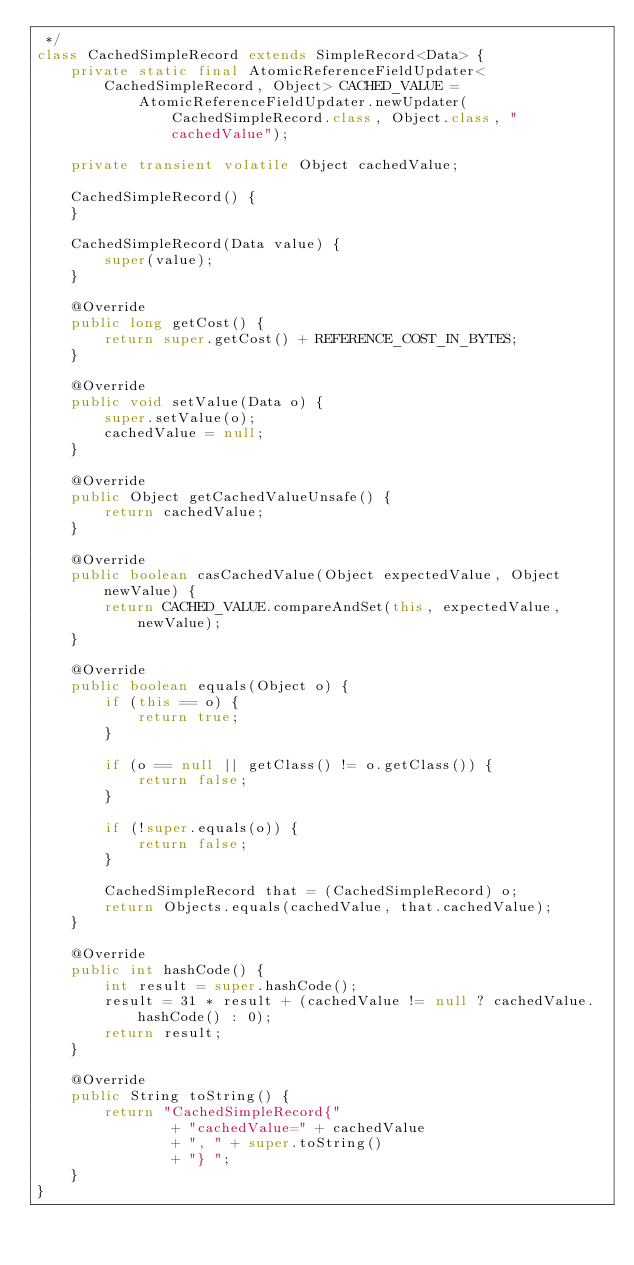<code> <loc_0><loc_0><loc_500><loc_500><_Java_> */
class CachedSimpleRecord extends SimpleRecord<Data> {
    private static final AtomicReferenceFieldUpdater<CachedSimpleRecord, Object> CACHED_VALUE =
            AtomicReferenceFieldUpdater.newUpdater(CachedSimpleRecord.class, Object.class, "cachedValue");

    private transient volatile Object cachedValue;

    CachedSimpleRecord() {
    }

    CachedSimpleRecord(Data value) {
        super(value);
    }

    @Override
    public long getCost() {
        return super.getCost() + REFERENCE_COST_IN_BYTES;
    }

    @Override
    public void setValue(Data o) {
        super.setValue(o);
        cachedValue = null;
    }

    @Override
    public Object getCachedValueUnsafe() {
        return cachedValue;
    }

    @Override
    public boolean casCachedValue(Object expectedValue, Object newValue) {
        return CACHED_VALUE.compareAndSet(this, expectedValue, newValue);
    }

    @Override
    public boolean equals(Object o) {
        if (this == o) {
            return true;
        }

        if (o == null || getClass() != o.getClass()) {
            return false;
        }

        if (!super.equals(o)) {
            return false;
        }

        CachedSimpleRecord that = (CachedSimpleRecord) o;
        return Objects.equals(cachedValue, that.cachedValue);
    }

    @Override
    public int hashCode() {
        int result = super.hashCode();
        result = 31 * result + (cachedValue != null ? cachedValue.hashCode() : 0);
        return result;
    }

    @Override
    public String toString() {
        return "CachedSimpleRecord{"
                + "cachedValue=" + cachedValue
                + ", " + super.toString()
                + "} ";
    }
}
</code> 